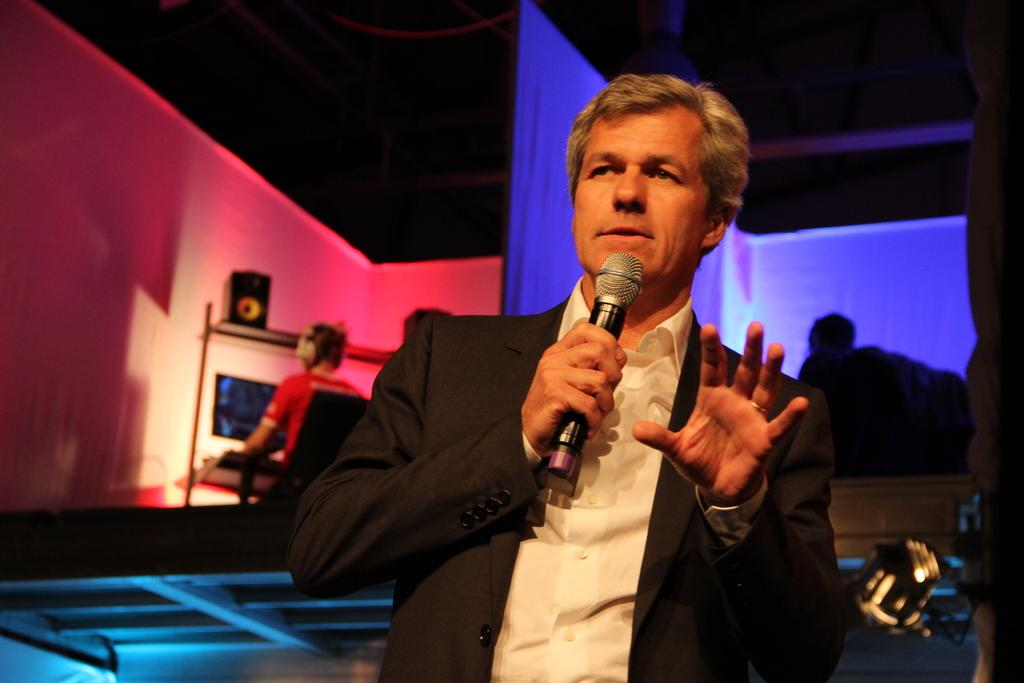What is the person in the image wearing? There is a person wearing a suit in the image. What is the person doing in front of the microphone? The person is speaking in front of a microphone. Can you describe the setting in which the person is speaking? There are two other persons behind the person speaking. What type of bridge can be seen in the background of the image? There is no bridge present in the image. What is the texture of the hobbies visible in the image? There is no reference to hobbies in the image. 